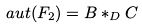<formula> <loc_0><loc_0><loc_500><loc_500>\ a u t ( F _ { 2 } ) = B * _ { D } C</formula> 